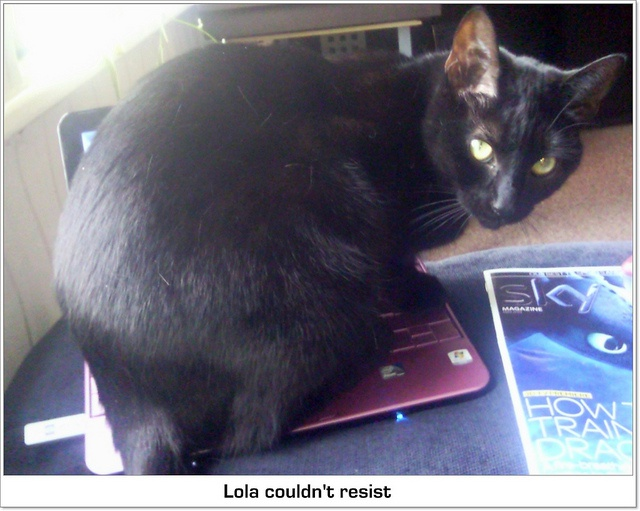Describe the objects in this image and their specific colors. I can see cat in darkgray, black, and gray tones, book in darkgray, white, and lightblue tones, and laptop in darkgray, black, purple, and violet tones in this image. 